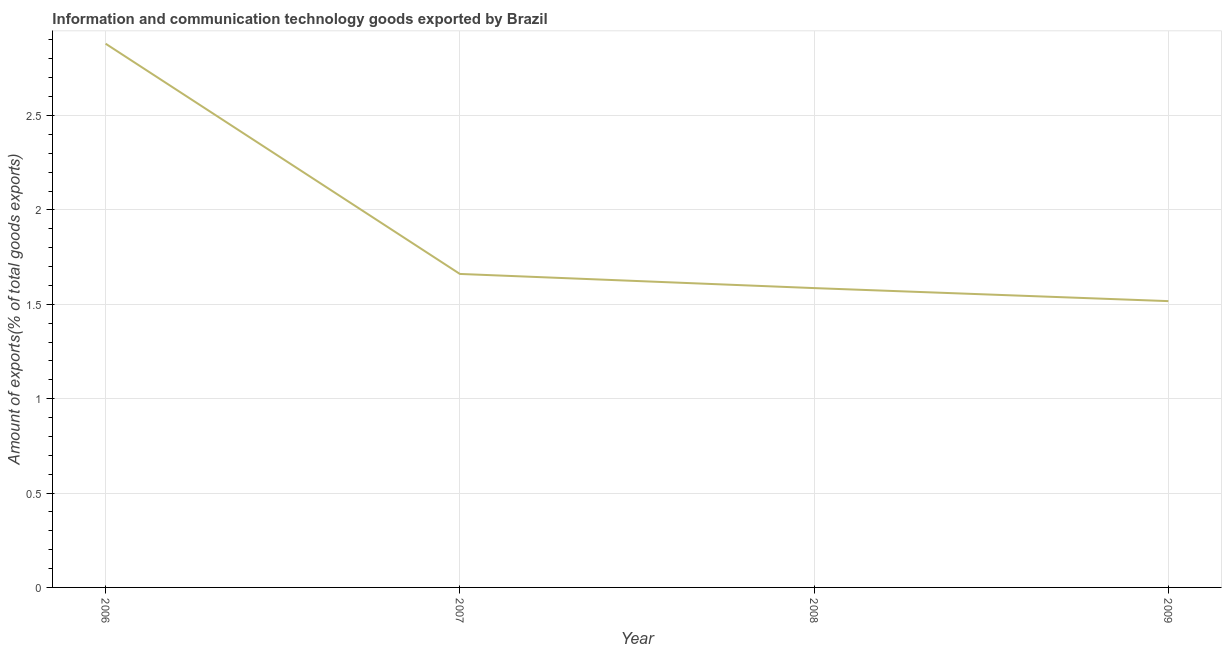What is the amount of ict goods exports in 2009?
Make the answer very short. 1.52. Across all years, what is the maximum amount of ict goods exports?
Offer a very short reply. 2.88. Across all years, what is the minimum amount of ict goods exports?
Your response must be concise. 1.52. What is the sum of the amount of ict goods exports?
Your answer should be very brief. 7.64. What is the difference between the amount of ict goods exports in 2006 and 2008?
Make the answer very short. 1.29. What is the average amount of ict goods exports per year?
Your answer should be very brief. 1.91. What is the median amount of ict goods exports?
Keep it short and to the point. 1.62. In how many years, is the amount of ict goods exports greater than 2.8 %?
Ensure brevity in your answer.  1. What is the ratio of the amount of ict goods exports in 2007 to that in 2009?
Offer a terse response. 1.09. What is the difference between the highest and the second highest amount of ict goods exports?
Your answer should be very brief. 1.22. What is the difference between the highest and the lowest amount of ict goods exports?
Your answer should be compact. 1.36. Does the amount of ict goods exports monotonically increase over the years?
Provide a succinct answer. No. How many lines are there?
Offer a very short reply. 1. How many years are there in the graph?
Provide a succinct answer. 4. What is the difference between two consecutive major ticks on the Y-axis?
Offer a very short reply. 0.5. Are the values on the major ticks of Y-axis written in scientific E-notation?
Give a very brief answer. No. Does the graph contain any zero values?
Offer a terse response. No. Does the graph contain grids?
Offer a terse response. Yes. What is the title of the graph?
Make the answer very short. Information and communication technology goods exported by Brazil. What is the label or title of the X-axis?
Your answer should be very brief. Year. What is the label or title of the Y-axis?
Offer a very short reply. Amount of exports(% of total goods exports). What is the Amount of exports(% of total goods exports) of 2006?
Provide a short and direct response. 2.88. What is the Amount of exports(% of total goods exports) of 2007?
Your answer should be very brief. 1.66. What is the Amount of exports(% of total goods exports) in 2008?
Keep it short and to the point. 1.59. What is the Amount of exports(% of total goods exports) in 2009?
Keep it short and to the point. 1.52. What is the difference between the Amount of exports(% of total goods exports) in 2006 and 2007?
Ensure brevity in your answer.  1.22. What is the difference between the Amount of exports(% of total goods exports) in 2006 and 2008?
Offer a terse response. 1.29. What is the difference between the Amount of exports(% of total goods exports) in 2006 and 2009?
Your answer should be very brief. 1.36. What is the difference between the Amount of exports(% of total goods exports) in 2007 and 2008?
Your answer should be compact. 0.07. What is the difference between the Amount of exports(% of total goods exports) in 2007 and 2009?
Your response must be concise. 0.14. What is the difference between the Amount of exports(% of total goods exports) in 2008 and 2009?
Your answer should be very brief. 0.07. What is the ratio of the Amount of exports(% of total goods exports) in 2006 to that in 2007?
Your answer should be compact. 1.73. What is the ratio of the Amount of exports(% of total goods exports) in 2006 to that in 2008?
Give a very brief answer. 1.82. What is the ratio of the Amount of exports(% of total goods exports) in 2006 to that in 2009?
Your answer should be compact. 1.9. What is the ratio of the Amount of exports(% of total goods exports) in 2007 to that in 2008?
Your response must be concise. 1.05. What is the ratio of the Amount of exports(% of total goods exports) in 2007 to that in 2009?
Your response must be concise. 1.09. What is the ratio of the Amount of exports(% of total goods exports) in 2008 to that in 2009?
Offer a very short reply. 1.05. 